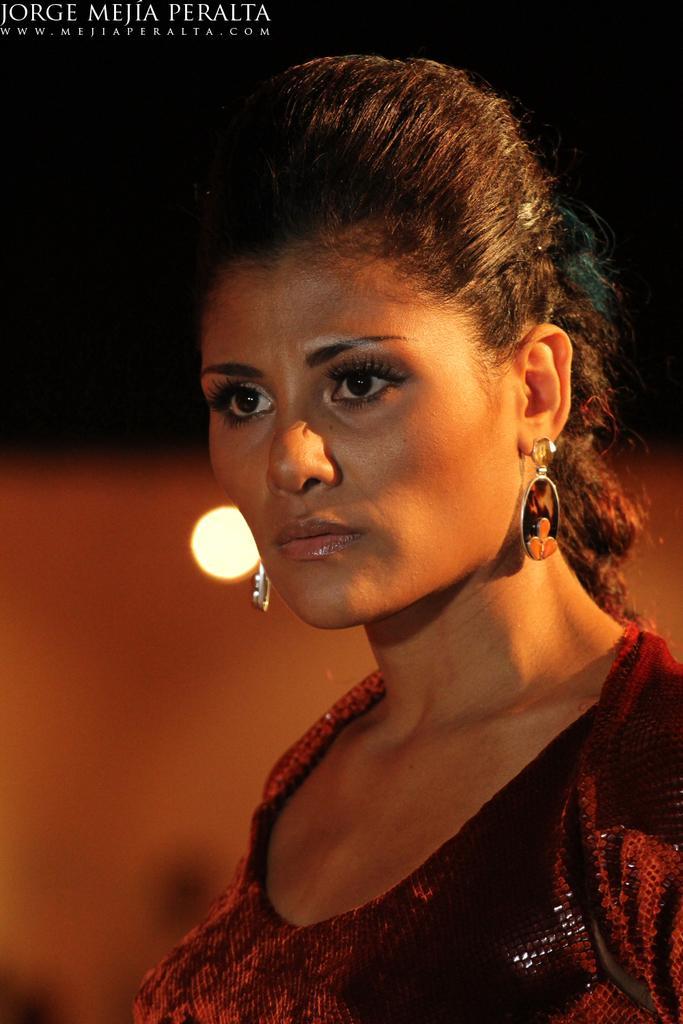Please provide a concise description of this image. On the right side, there is a woman watching something. On the top right, there is a watermark. In the background, there is light. 